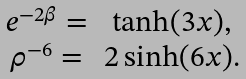<formula> <loc_0><loc_0><loc_500><loc_500>\begin{array} { c c } e ^ { - 2 \beta } = & \tanh ( 3 x ) , \\ \rho ^ { - 6 } = & 2 \sinh ( 6 x ) . \end{array}</formula> 